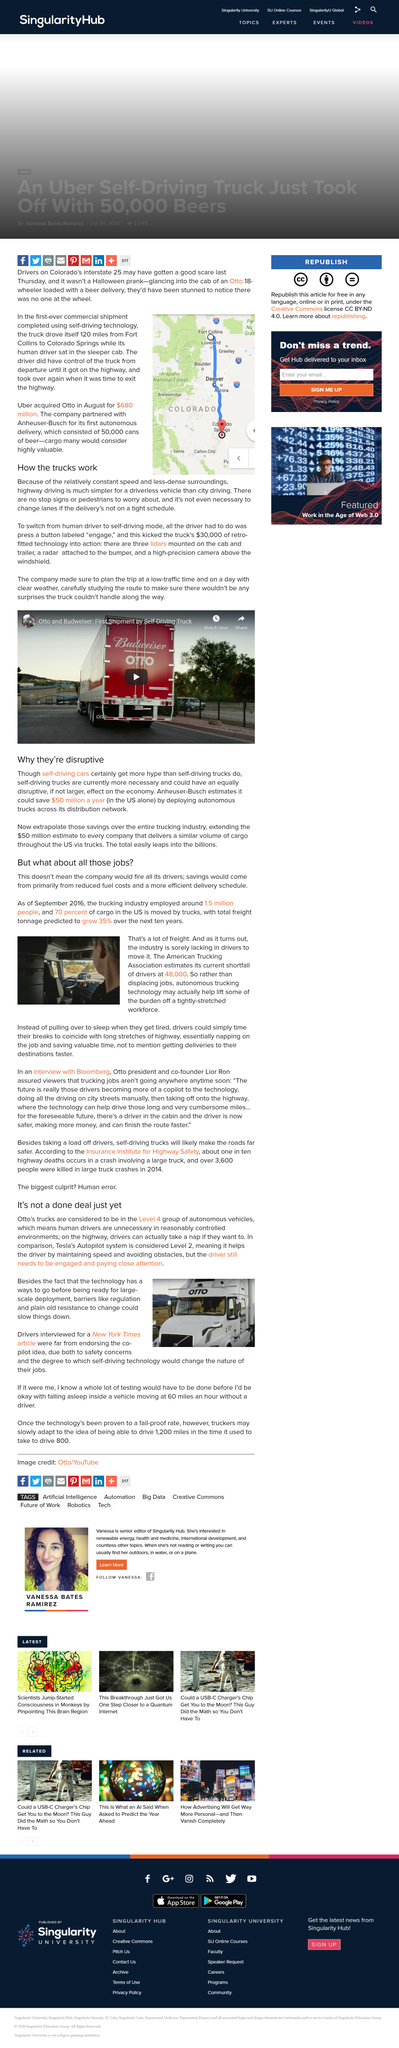Give some essential details in this illustration. Uber paid $680 million for the acquisition of Otto, a self-driving truck company. Anheuser-Busch's first autonomous delivery was transported with 50,000 cans of beer. The depicted route on the map is approximately 120 miles in length. 